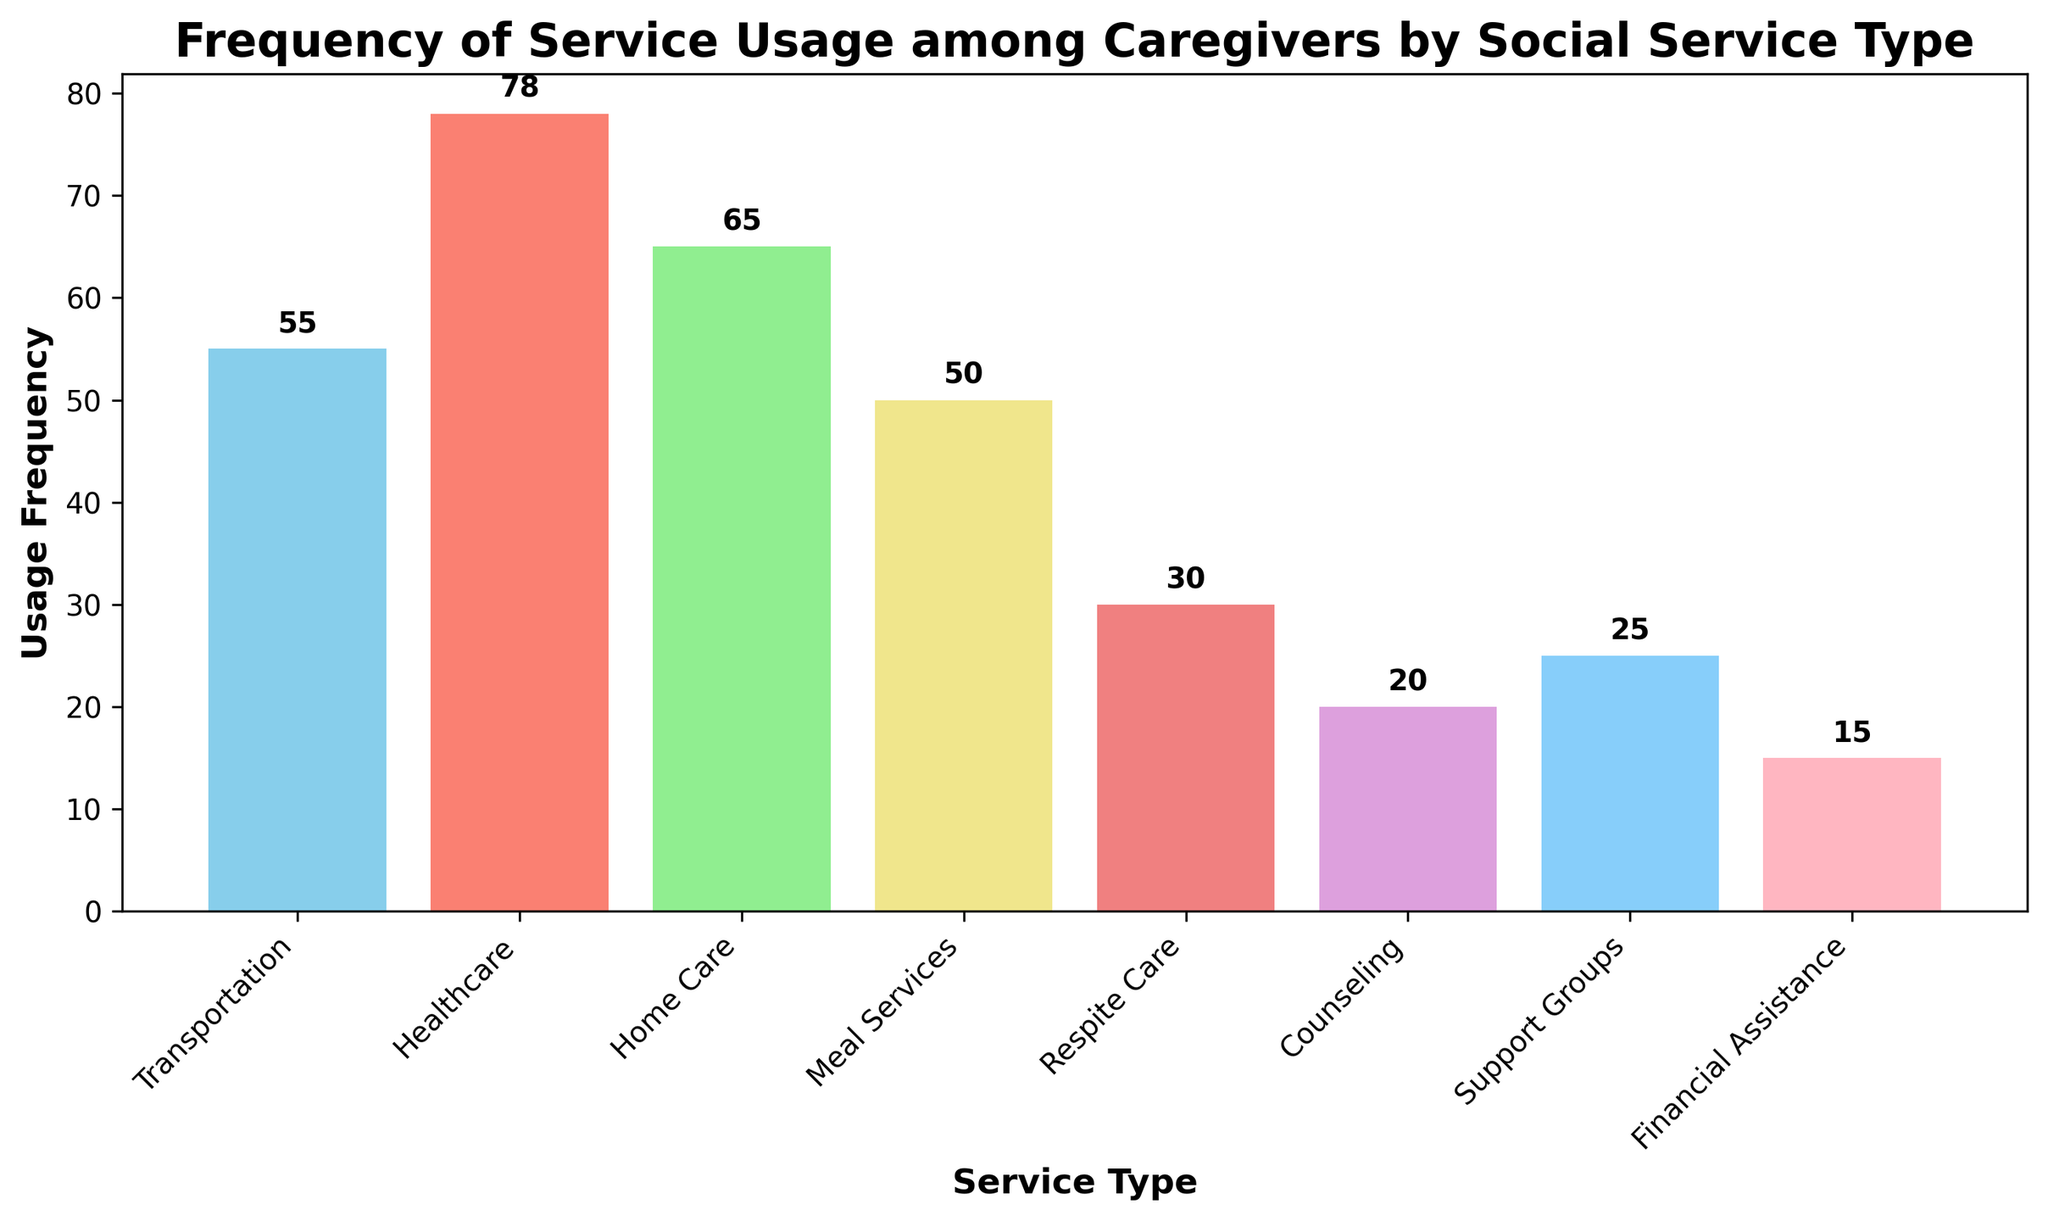Which social service type is used most frequently by caregivers? The bar representing 'Healthcare' has the highest height among all the bars, indicating the highest usage frequency.
Answer: Healthcare Which service type is used least frequently by caregivers? The bar representing 'Financial Assistance' has the lowest height among all the bars, indicating the lowest usage frequency.
Answer: Financial Assistance What is the total usage frequency for 'Transportation' and 'Meal Services' combined? The usage frequency for 'Transportation' is 55 and for 'Meal Services' is 50. Adding these together gives 55 + 50 = 105.
Answer: 105 Is the usage frequency of 'Support Groups' higher than 'Counseling'? The usage frequency for 'Support Groups' is 25, while for 'Counseling' it is 20. Since 25 is greater than 20, 'Support Groups' has a higher usage frequency than 'Counseling'.
Answer: Yes How much more frequently is 'Healthcare' used compared to 'Respite Care'? The usage frequency of 'Healthcare' is 78 and 'Respite Care' is 30. Subtracting the two gives 78 - 30 = 48.
Answer: 48 What is the average usage frequency of 'Home Care', 'Meal Services', and 'Support Groups'? The usage frequencies for 'Home Care' is 65, 'Meal Services' is 50, and 'Support Groups' is 25. The sum is 65 + 50 + 25 = 140. The average is 140 / 3 ≈ 46.67.
Answer: 46.67 Which two service types have the closest usage frequency? The bars representing 'Support Groups' and 'Counseling' are closest in height, with frequencies of 25 and 20 respectively. The difference is 5 which is smaller than the difference between any other pairs of services.
Answer: Support Groups and Counseling What is the difference in usage frequency between the most frequently and least frequently used services? The most frequently used service is 'Healthcare' with a frequency of 78, and the least frequently used is 'Financial Assistance' with a frequency of 15. The difference is 78 - 15 = 63.
Answer: 63 What percentage of total usage frequency does 'Home Care' account for (approximately)? First, sum the usage frequencies of all services: 55 + 78 + 65 + 50 + 30 + 20 + 25 + 15 = 338. The frequency for 'Home Care' is 65. The percentage is (65 / 338) * 100 ≈ 19.23%.
Answer: 19.23% Are there more service types with a usage frequency above 50 or below 50? The service types above 50 include 'Transportation', 'Healthcare', 'Home Care', and 'Meal Services' (4). The service types below 50 include 'Respite Care', 'Counseling', 'Support Groups', and 'Financial Assistance' (4). The numbers are equal.
Answer: Equal 